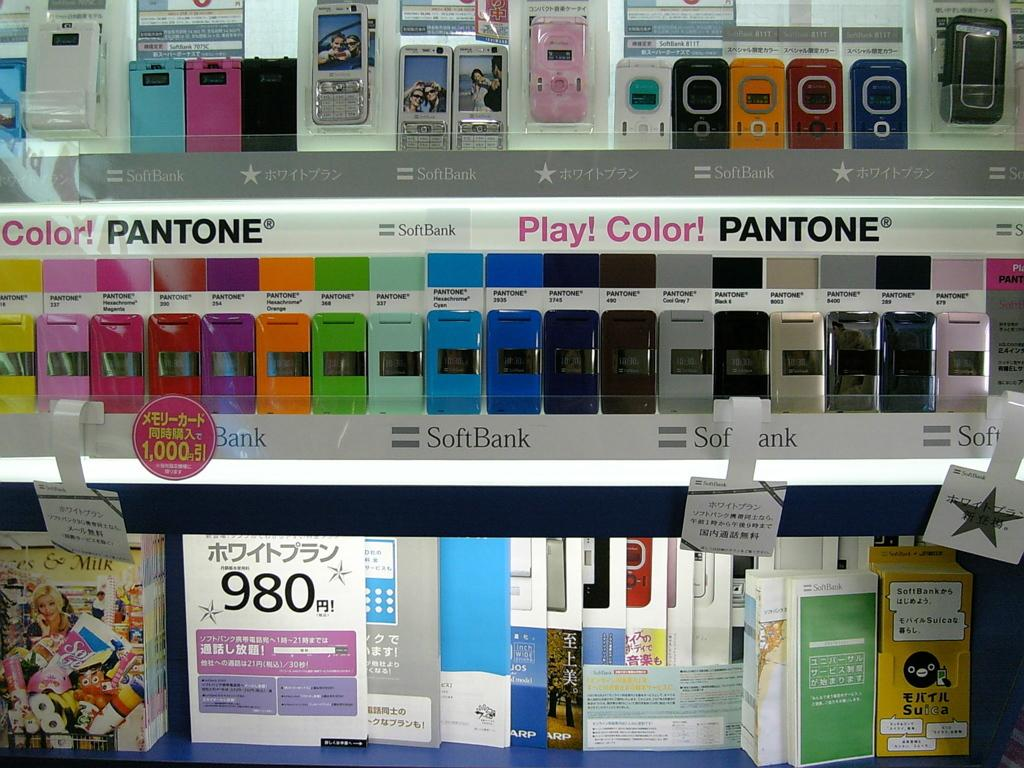<image>
Offer a succinct explanation of the picture presented. a shelf of different colored phones with a sign underneath that has the number 980 on it 